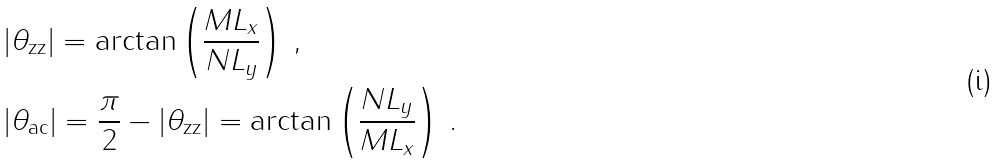<formula> <loc_0><loc_0><loc_500><loc_500>& | \theta _ { \text {zz} } | = \arctan \left ( \frac { M L _ { x } } { N L _ { y } } \right ) \, , \\ & | \theta _ { \text {ac} } | = \frac { \pi } { 2 } - | \theta _ { \text {zz} } | = \arctan \left ( \frac { N L _ { y } } { M L _ { x } } \right ) \, .</formula> 